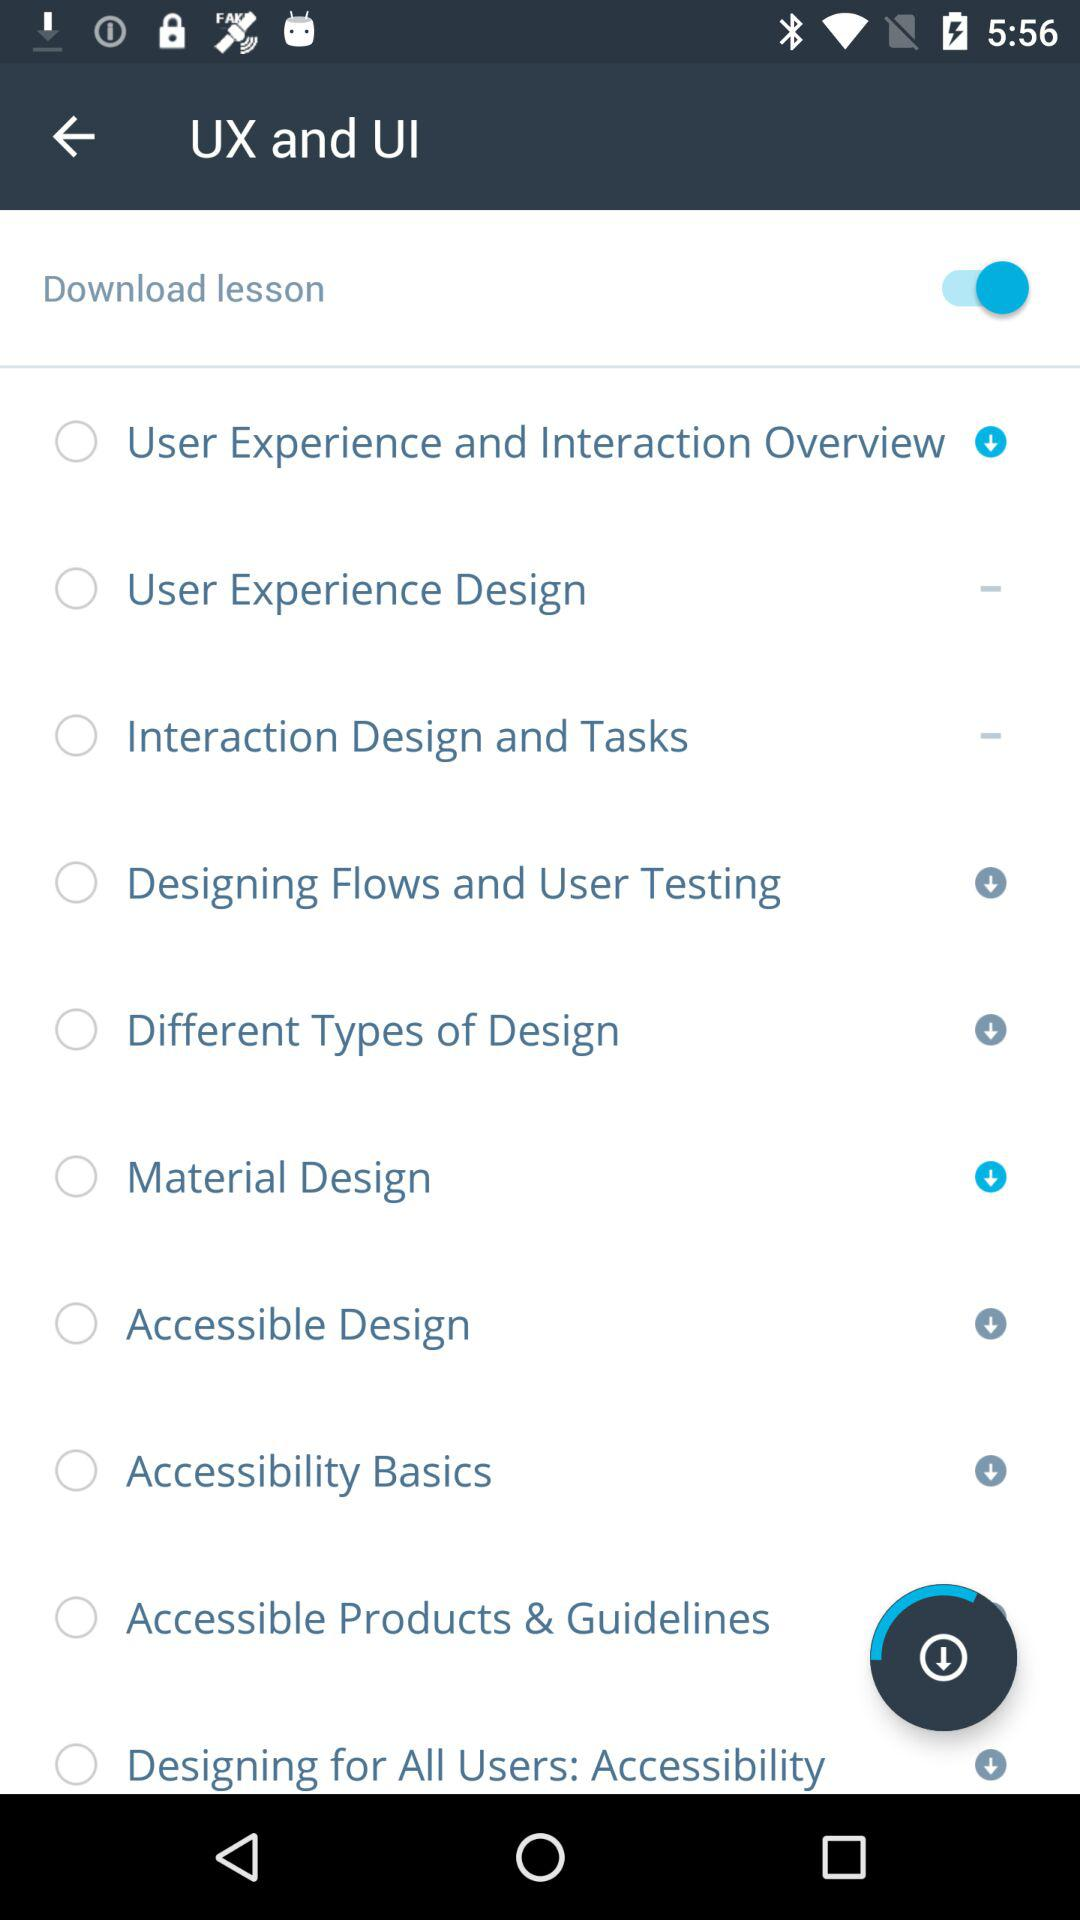How many lessons are there in total?
Answer the question using a single word or phrase. 10 